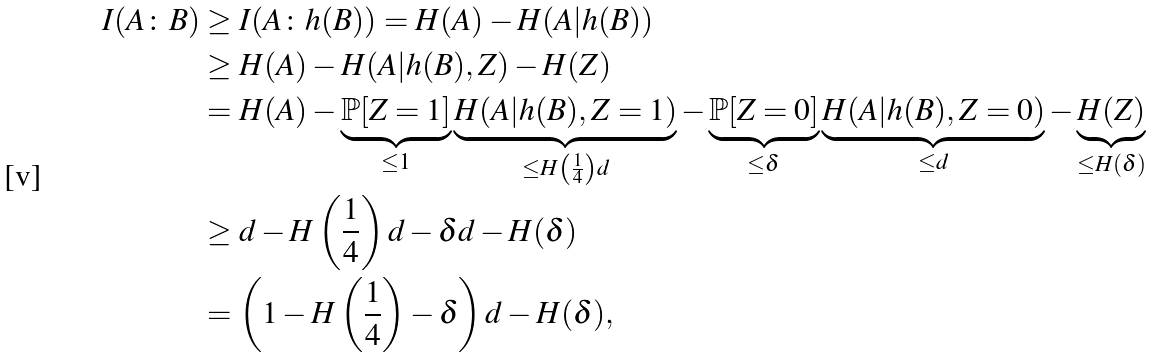Convert formula to latex. <formula><loc_0><loc_0><loc_500><loc_500>I ( A \colon B ) & \geq I ( A \colon h ( B ) ) = H ( A ) - H ( A | h ( B ) ) \\ & \geq H ( A ) - H ( A | h ( B ) , Z ) - H ( Z ) \\ & = H ( A ) - \underbrace { \mathbb { P } [ Z = 1 ] } _ { \leq 1 } \underbrace { H ( A | h ( B ) , Z = 1 ) } _ { \leq H \left ( \frac { 1 } { 4 } \right ) d } - \underbrace { \mathbb { P } [ Z = 0 ] } _ { \leq \delta } \underbrace { H ( A | h ( B ) , Z = 0 ) } _ { \leq d } - \underbrace { H ( Z ) } _ { \leq H ( \delta ) } \\ & \geq d - H \left ( \frac { 1 } { 4 } \right ) d - \delta d - H ( \delta ) \\ & = \left ( 1 - H \left ( \frac { 1 } { 4 } \right ) - \delta \right ) d - H ( \delta ) ,</formula> 